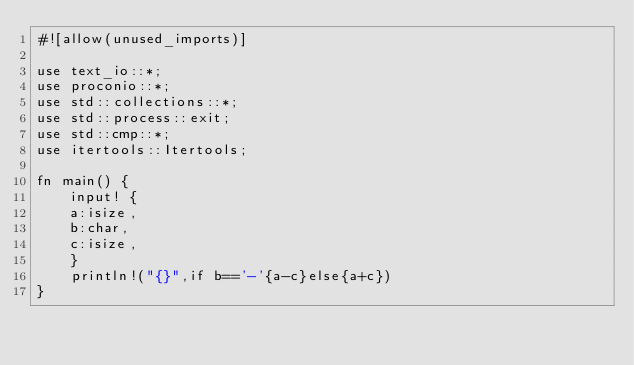Convert code to text. <code><loc_0><loc_0><loc_500><loc_500><_Rust_>#![allow(unused_imports)]

use text_io::*;
use proconio::*;
use std::collections::*;
use std::process::exit;
use std::cmp::*;
use itertools::Itertools;

fn main() {
    input! {
    a:isize,
    b:char,
    c:isize,
    }
    println!("{}",if b=='-'{a-c}else{a+c})
}</code> 